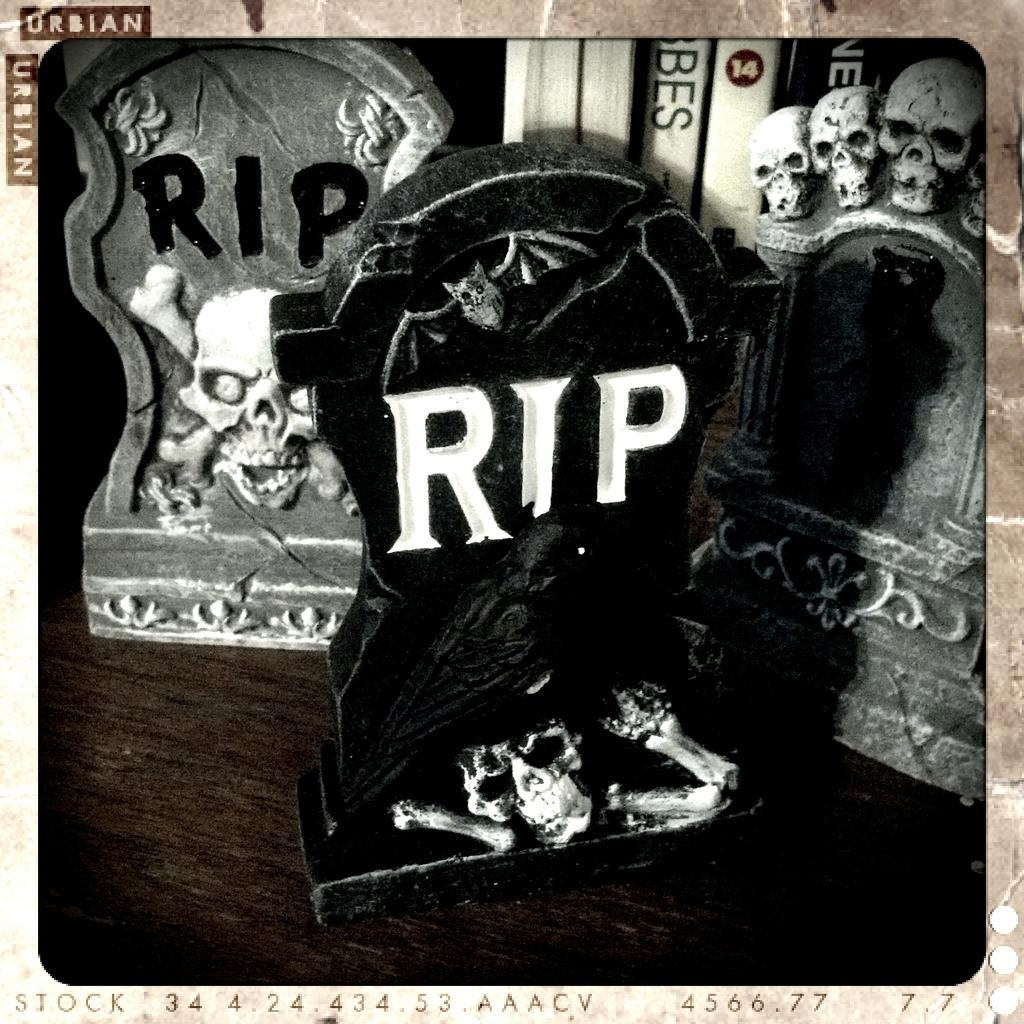<image>
Create a compact narrative representing the image presented. a few tombstones with RIP labelled on them 